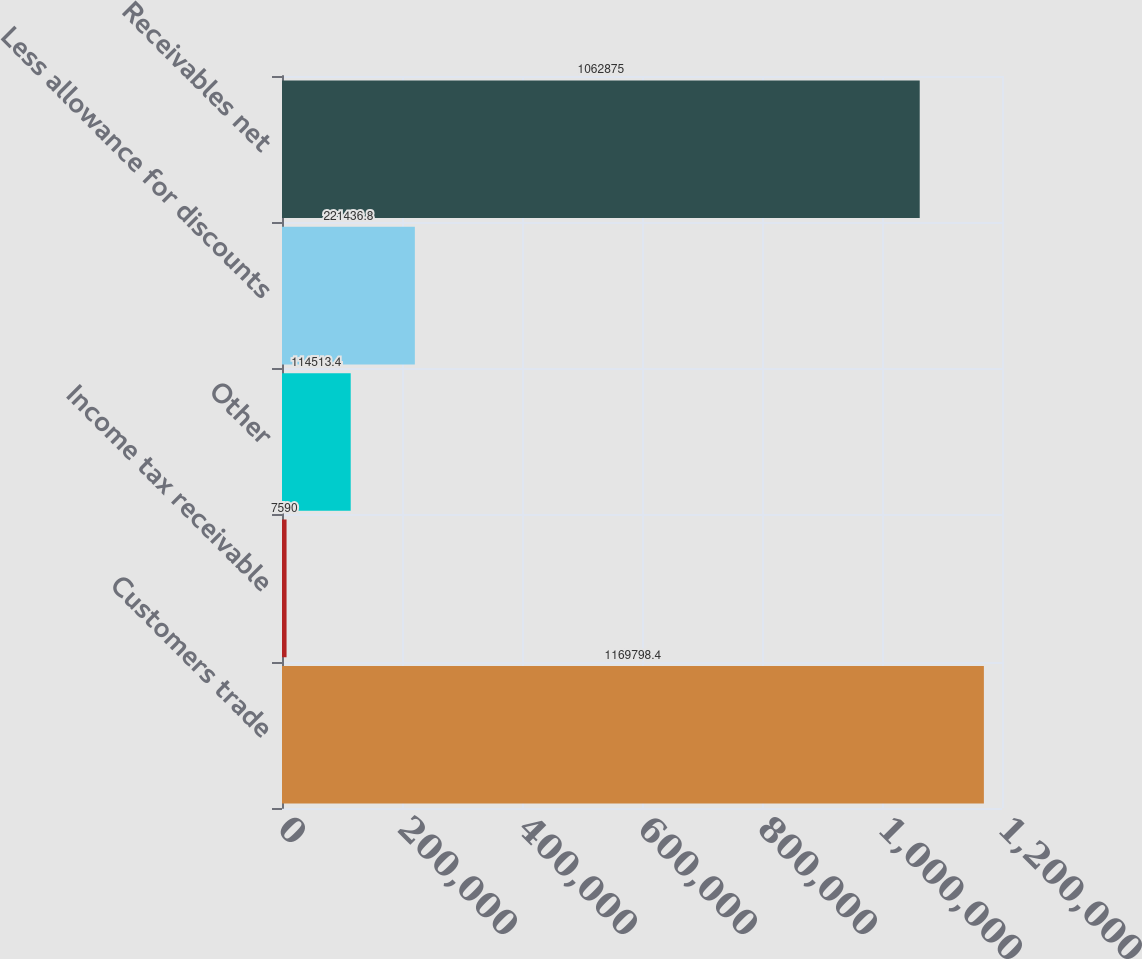Convert chart to OTSL. <chart><loc_0><loc_0><loc_500><loc_500><bar_chart><fcel>Customers trade<fcel>Income tax receivable<fcel>Other<fcel>Less allowance for discounts<fcel>Receivables net<nl><fcel>1.1698e+06<fcel>7590<fcel>114513<fcel>221437<fcel>1.06288e+06<nl></chart> 